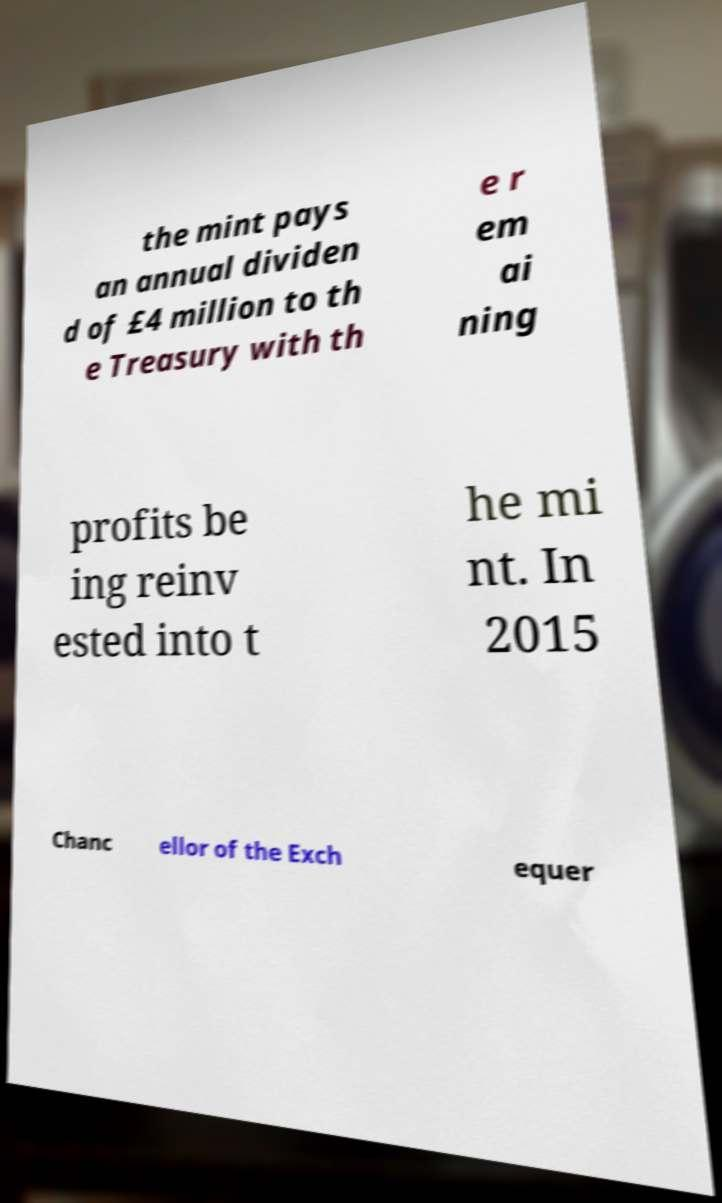There's text embedded in this image that I need extracted. Can you transcribe it verbatim? the mint pays an annual dividen d of £4 million to th e Treasury with th e r em ai ning profits be ing reinv ested into t he mi nt. In 2015 Chanc ellor of the Exch equer 